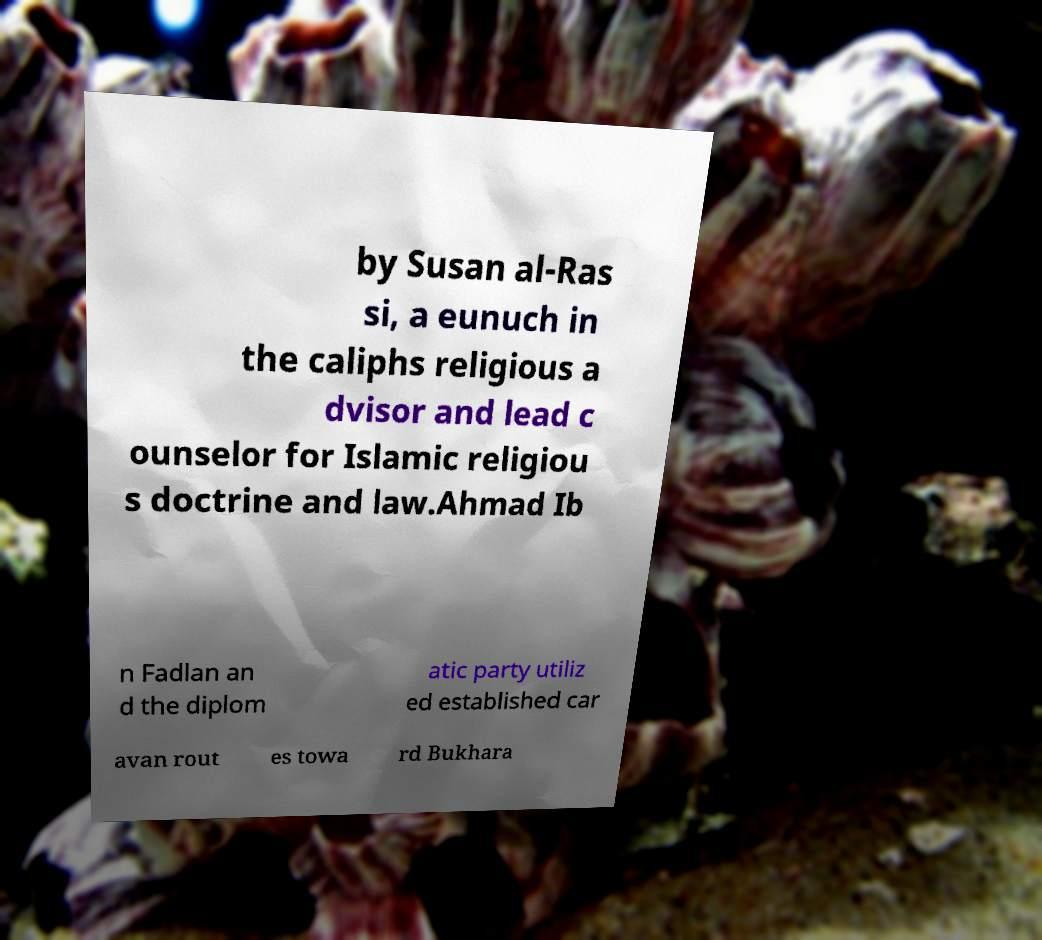Please identify and transcribe the text found in this image. by Susan al-Ras si, a eunuch in the caliphs religious a dvisor and lead c ounselor for Islamic religiou s doctrine and law.Ahmad Ib n Fadlan an d the diplom atic party utiliz ed established car avan rout es towa rd Bukhara 